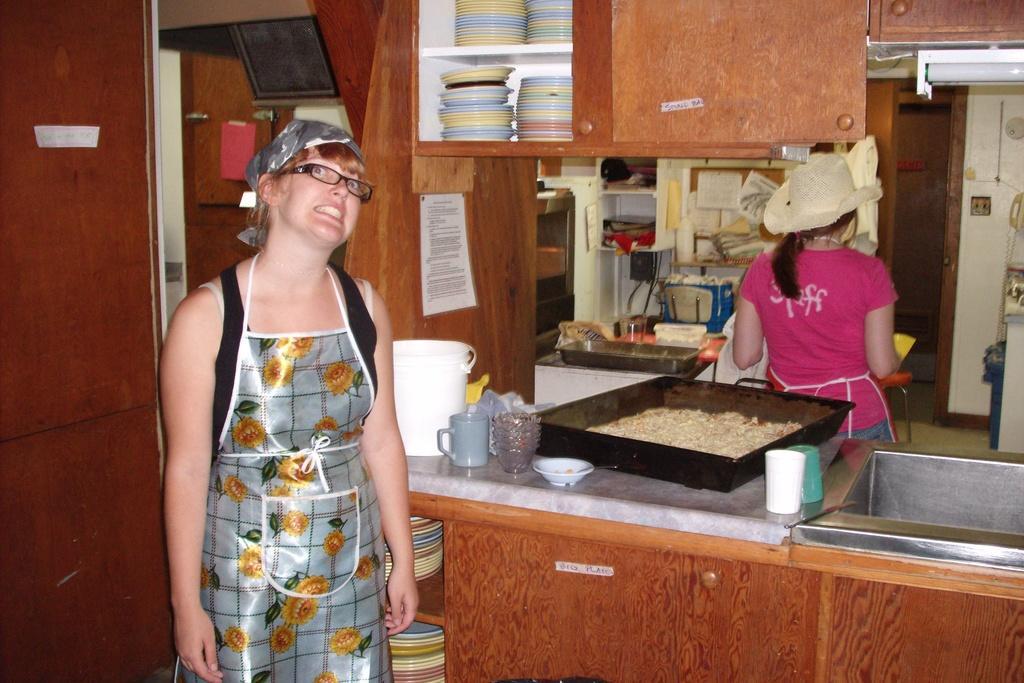Can you describe this image briefly? In this image in the foreground there is a woman behind the woman there is a kitchen room, in the room there is a desk, there is a tray ,bowl cup, bucket, under it there are some plates, at the top there is a cupboard, in the cup board there are some plates, in the middle there is a woman wall, tray, bowl, glass, some other objects visible, on the right side there is a light, wall. 